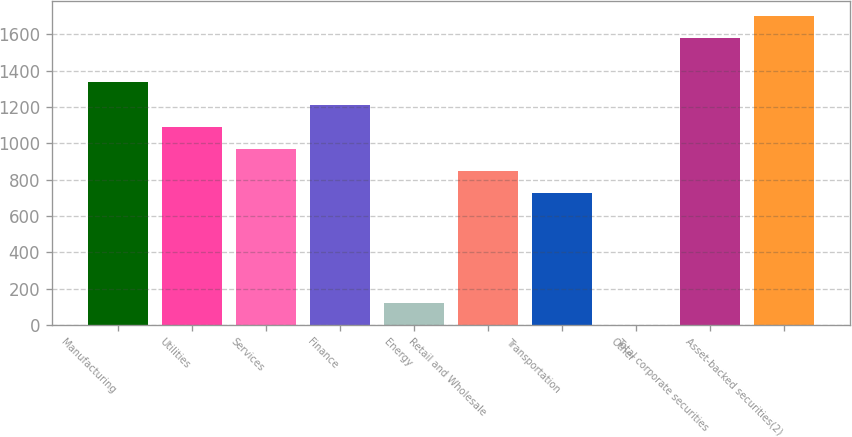<chart> <loc_0><loc_0><loc_500><loc_500><bar_chart><fcel>Manufacturing<fcel>Utilities<fcel>Services<fcel>Finance<fcel>Energy<fcel>Retail and Wholesale<fcel>Transportation<fcel>Other<fcel>Total corporate securities<fcel>Asset-backed securities(2)<nl><fcel>1335.28<fcel>1092.64<fcel>971.32<fcel>1213.96<fcel>122.08<fcel>850<fcel>728.68<fcel>0.76<fcel>1577.92<fcel>1699.24<nl></chart> 